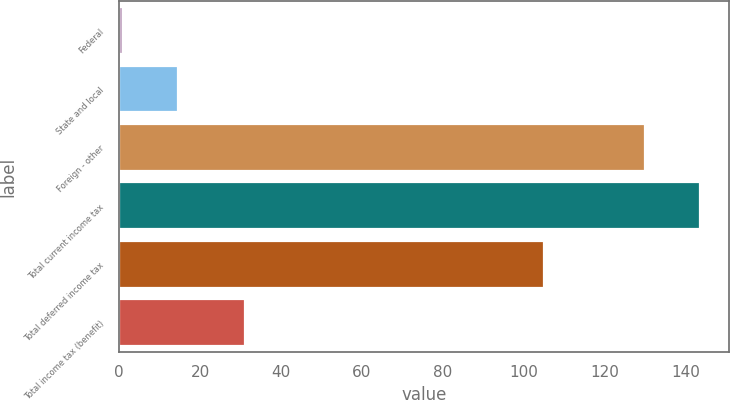<chart> <loc_0><loc_0><loc_500><loc_500><bar_chart><fcel>Federal<fcel>State and local<fcel>Foreign - other<fcel>Total current income tax<fcel>Total deferred income tax<fcel>Total income tax (benefit)<nl><fcel>1<fcel>14.5<fcel>130<fcel>143.5<fcel>105<fcel>31<nl></chart> 